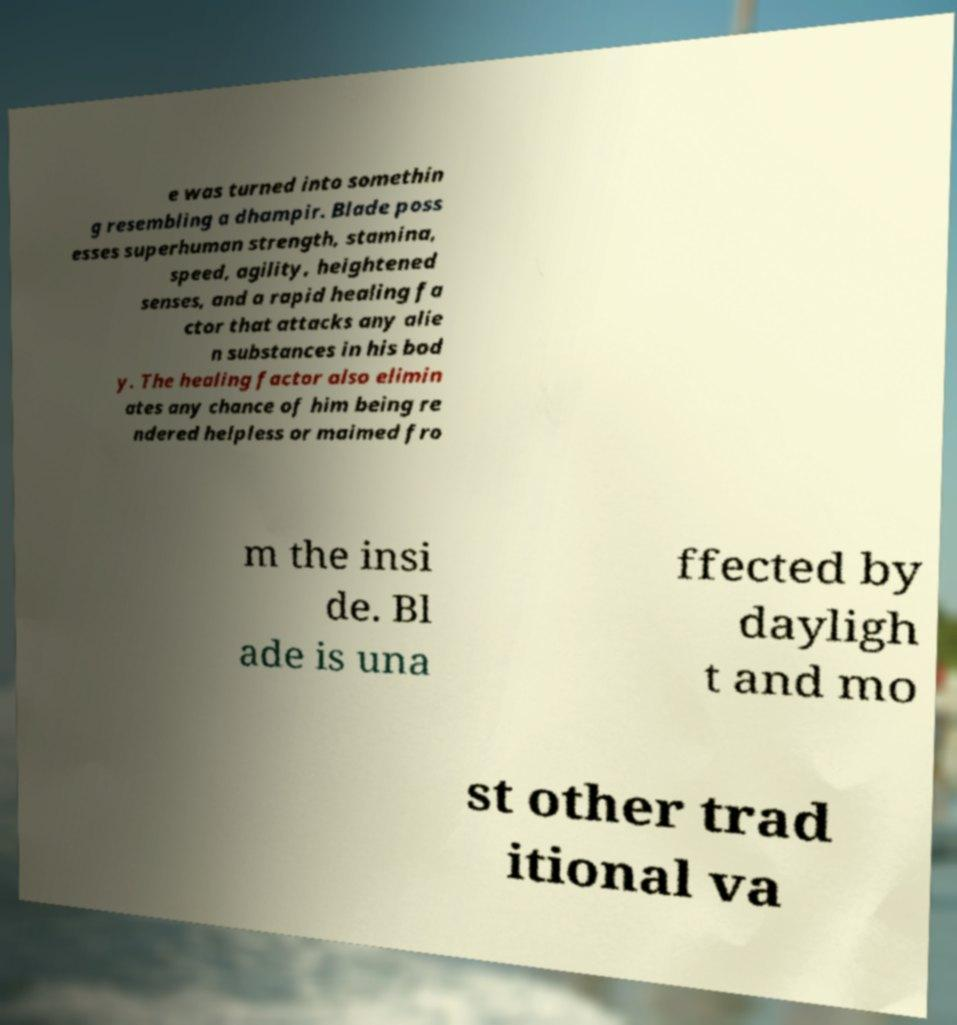Can you accurately transcribe the text from the provided image for me? e was turned into somethin g resembling a dhampir. Blade poss esses superhuman strength, stamina, speed, agility, heightened senses, and a rapid healing fa ctor that attacks any alie n substances in his bod y. The healing factor also elimin ates any chance of him being re ndered helpless or maimed fro m the insi de. Bl ade is una ffected by dayligh t and mo st other trad itional va 